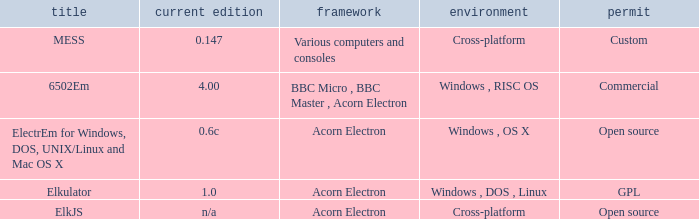Which system is named ELKJS? Acorn Electron. 